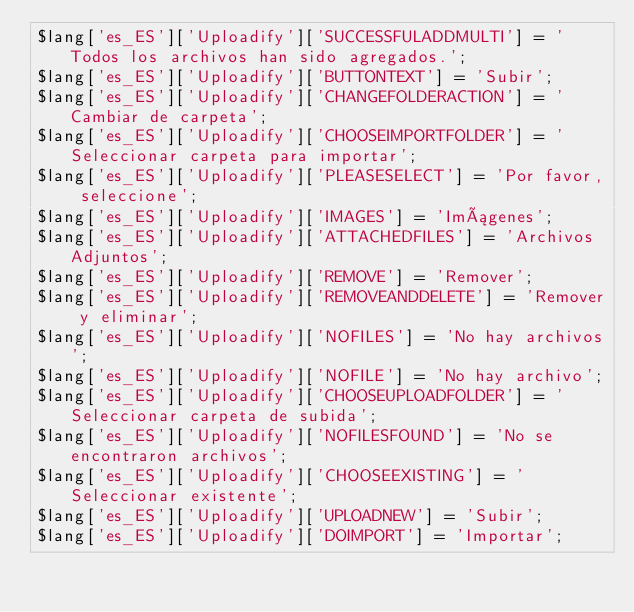<code> <loc_0><loc_0><loc_500><loc_500><_PHP_>$lang['es_ES']['Uploadify']['SUCCESSFULADDMULTI'] = 'Todos los archivos han sido agregados.';
$lang['es_ES']['Uploadify']['BUTTONTEXT'] = 'Subir';
$lang['es_ES']['Uploadify']['CHANGEFOLDERACTION'] = 'Cambiar de carpeta';
$lang['es_ES']['Uploadify']['CHOOSEIMPORTFOLDER'] = 'Seleccionar carpeta para importar';
$lang['es_ES']['Uploadify']['PLEASESELECT'] = 'Por favor, seleccione';
$lang['es_ES']['Uploadify']['IMAGES'] = 'Imágenes';
$lang['es_ES']['Uploadify']['ATTACHEDFILES'] = 'Archivos Adjuntos';
$lang['es_ES']['Uploadify']['REMOVE'] = 'Remover';
$lang['es_ES']['Uploadify']['REMOVEANDDELETE'] = 'Remover y eliminar';
$lang['es_ES']['Uploadify']['NOFILES'] = 'No hay archivos';
$lang['es_ES']['Uploadify']['NOFILE'] = 'No hay archivo';
$lang['es_ES']['Uploadify']['CHOOSEUPLOADFOLDER'] = 'Seleccionar carpeta de subida';
$lang['es_ES']['Uploadify']['NOFILESFOUND'] = 'No se encontraron archivos';
$lang['es_ES']['Uploadify']['CHOOSEEXISTING'] = 'Seleccionar existente';
$lang['es_ES']['Uploadify']['UPLOADNEW'] = 'Subir';
$lang['es_ES']['Uploadify']['DOIMPORT'] = 'Importar';
</code> 